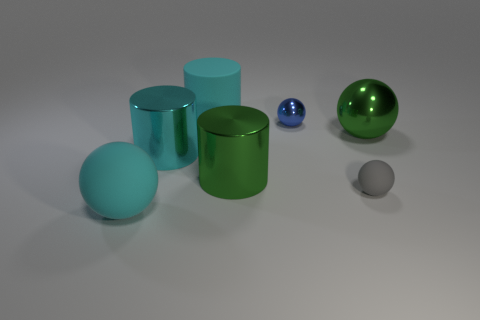Does the big green ball have the same material as the gray object?
Make the answer very short. No. How many matte objects are either cylinders or tiny blue cylinders?
Ensure brevity in your answer.  1. The cyan rubber object that is on the left side of the big cyan metal cylinder has what shape?
Offer a very short reply. Sphere. There is a cyan cylinder that is the same material as the small gray ball; what is its size?
Your answer should be compact. Large. The matte object that is both to the left of the tiny gray rubber sphere and on the right side of the big cyan shiny thing has what shape?
Your answer should be very brief. Cylinder. Is the color of the cylinder in front of the big cyan shiny thing the same as the tiny matte ball?
Offer a terse response. No. There is a big metal object to the right of the green metal cylinder; does it have the same shape as the large cyan matte thing that is behind the tiny blue object?
Your answer should be very brief. No. How big is the cyan cylinder that is left of the large cyan matte cylinder?
Offer a terse response. Large. There is a green thing left of the tiny ball that is behind the large green metallic sphere; what size is it?
Give a very brief answer. Large. Are there more blue shiny balls than large cyan rubber objects?
Provide a short and direct response. No. 